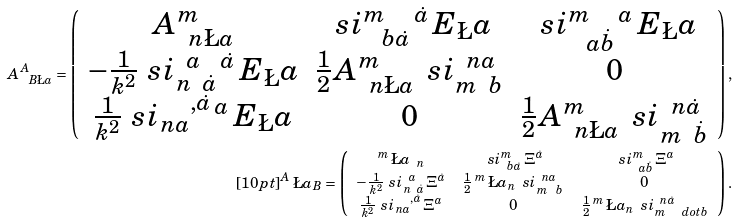<formula> <loc_0><loc_0><loc_500><loc_500>A ^ { A } _ { \ B \L a } = \left ( \begin{array} { c c c } A ^ { m } _ { \ \, n \L a } & \ s i ^ { m } _ { \ \ b \dot { a } } \, ^ { \dot { a } } \, E _ { \L } a & \ s i ^ { m } _ { \ \ a \dot { b } } \, ^ { a } \, E _ { \L } a \\ - \frac { 1 } { k ^ { 2 } } \ s i _ { n \ \, \dot { a } } ^ { \ \, a } \, ^ { \dot { a } } \, E _ { \L } a & \frac { 1 } { 2 } A ^ { m } _ { \ \, n \L a } \, \ s i _ { m \ \, b } ^ { \ \, n a } & 0 \\ \frac { 1 } { k ^ { 2 } } \ s i _ { n a } ^ { \quad , \dot { a } } \, ^ { a } \, E _ { \L } a & 0 & \frac { 1 } { 2 } A ^ { m } _ { \ \, n \L a } \, \ s i _ { m \ \, \dot { b } } ^ { \ \, n \dot { a } } \end{array} \right ) , \\ [ 1 0 p t ] ^ { A } \, \L a _ { B } = \left ( \begin{array} { c c c } ^ { m } \, \L a _ { \, \ n } & \ s i ^ { m } _ { \ \, b \dot { a } } \, \Xi ^ { \dot { a } } & \ s i ^ { m } _ { \ \, a \dot { b } } \, \Xi ^ { a } \\ - \frac { 1 } { k ^ { 2 } } \ s i _ { n \ \, \dot { a } } ^ { \ \, a } \, \Xi ^ { \dot { a } } & \frac { 1 } { 2 } \, ^ { m } \, \L a _ { n } \, \ s i _ { m \ \ b } ^ { \ \, n a } & 0 \\ \frac { 1 } { k ^ { 2 } } \ s i _ { n a } ^ { \quad , \dot { a } } \, \Xi ^ { a } & 0 & \frac { 1 } { 2 } \, ^ { m } \, \L a _ { n } \, \ s i _ { m \quad d o t { b } } ^ { \ \, n \dot { a } } \end{array} \right ) .</formula> 